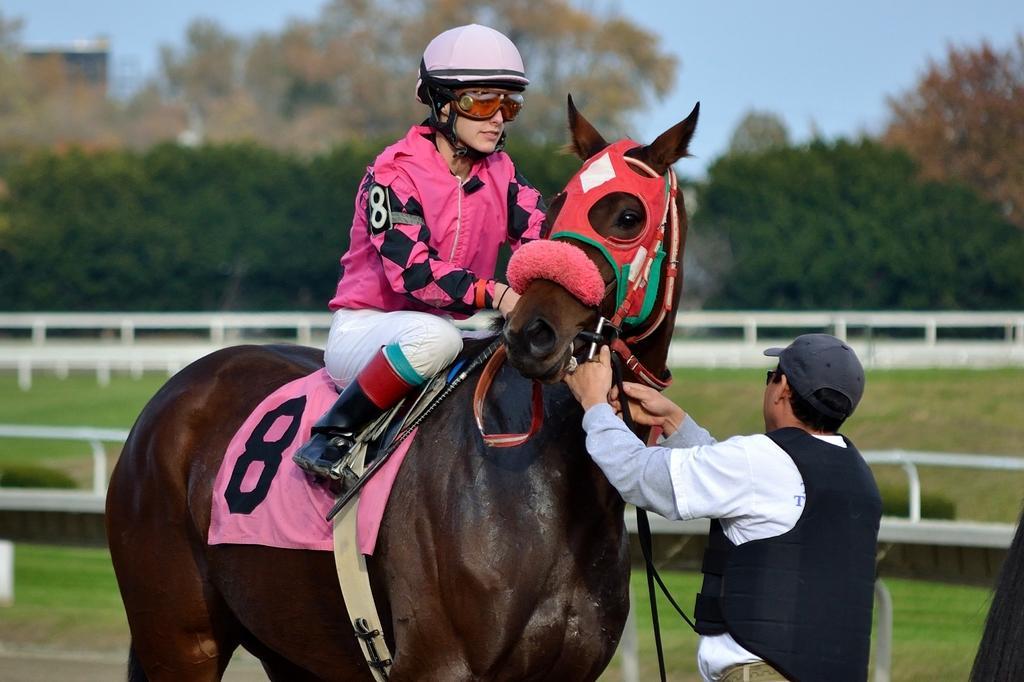Please provide a concise description of this image. In this image we can see a lady sitting on the horse. On the right there is a man standing. In the background there are trees and sky. We can see a fence. 